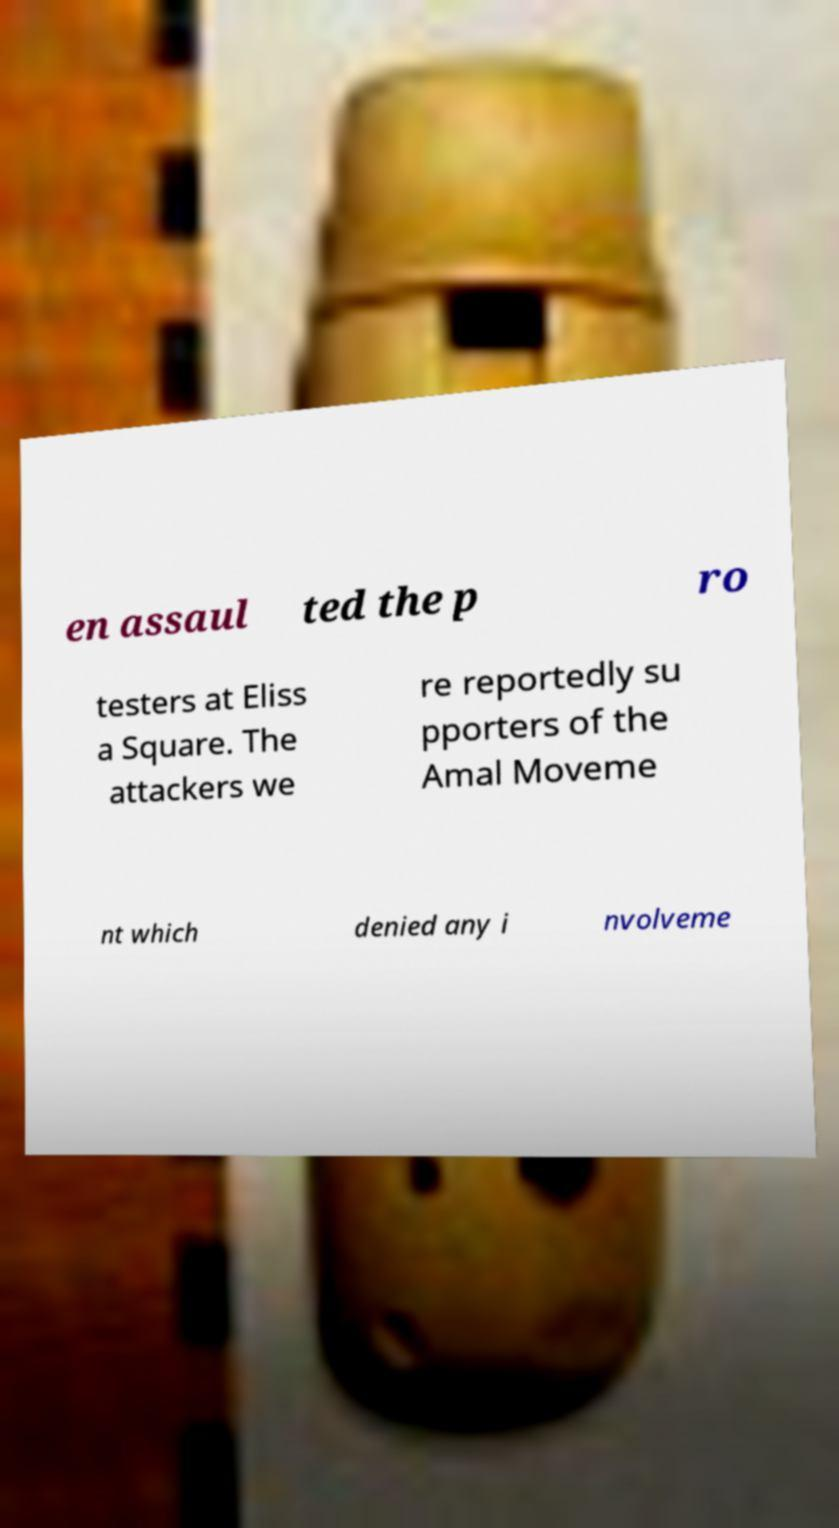Could you extract and type out the text from this image? en assaul ted the p ro testers at Eliss a Square. The attackers we re reportedly su pporters of the Amal Moveme nt which denied any i nvolveme 